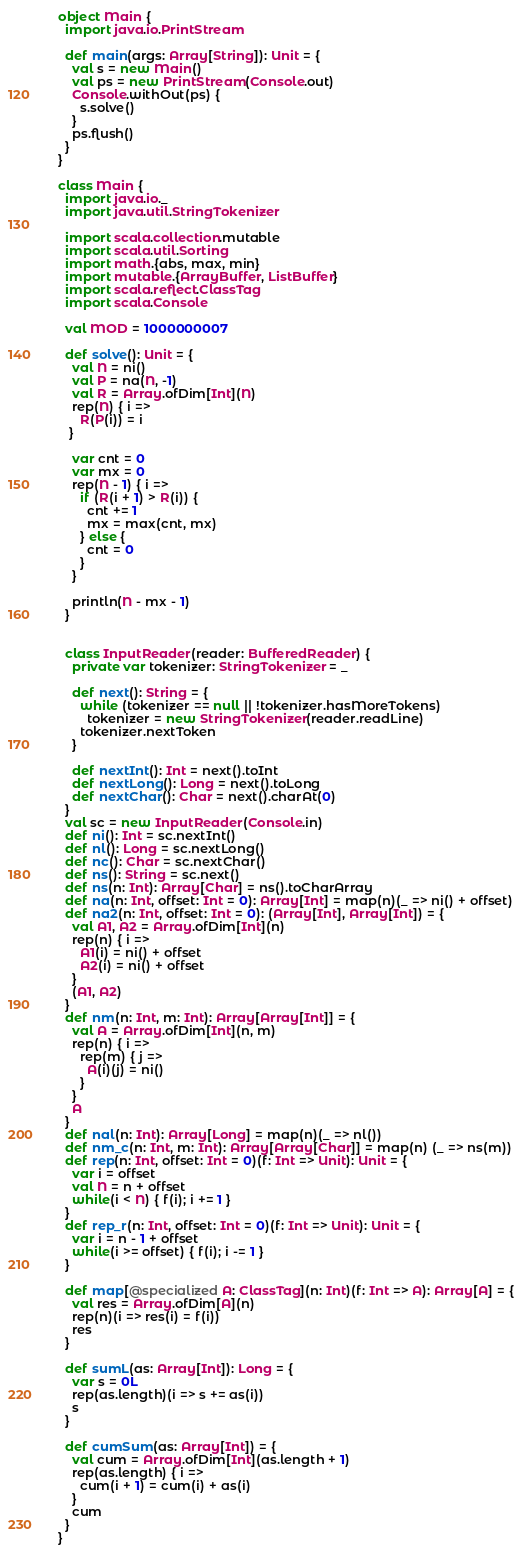<code> <loc_0><loc_0><loc_500><loc_500><_Scala_>object Main {
  import java.io.PrintStream

  def main(args: Array[String]): Unit = {
    val s = new Main()
    val ps = new PrintStream(Console.out)
    Console.withOut(ps) {
      s.solve()
    }
    ps.flush()
  }
}

class Main {
  import java.io._
  import java.util.StringTokenizer

  import scala.collection.mutable
  import scala.util.Sorting
  import math.{abs, max, min}
  import mutable.{ArrayBuffer, ListBuffer}
  import scala.reflect.ClassTag
  import scala.Console

  val MOD = 1000000007

  def solve(): Unit = {
    val N = ni()
    val P = na(N, -1)
    val R = Array.ofDim[Int](N)
    rep(N) { i =>
      R(P(i)) = i
   }

    var cnt = 0
    var mx = 0
    rep(N - 1) { i =>
      if (R(i + 1) > R(i)) {
        cnt += 1
        mx = max(cnt, mx)
      } else {
        cnt = 0
      }
    }

    println(N - mx - 1)
  }


  class InputReader(reader: BufferedReader) {
    private var tokenizer: StringTokenizer = _

    def next(): String = {
      while (tokenizer == null || !tokenizer.hasMoreTokens)
        tokenizer = new StringTokenizer(reader.readLine)
      tokenizer.nextToken
    }

    def nextInt(): Int = next().toInt
    def nextLong(): Long = next().toLong
    def nextChar(): Char = next().charAt(0)
  }
  val sc = new InputReader(Console.in)
  def ni(): Int = sc.nextInt()
  def nl(): Long = sc.nextLong()
  def nc(): Char = sc.nextChar()
  def ns(): String = sc.next()
  def ns(n: Int): Array[Char] = ns().toCharArray
  def na(n: Int, offset: Int = 0): Array[Int] = map(n)(_ => ni() + offset)
  def na2(n: Int, offset: Int = 0): (Array[Int], Array[Int]) = {
    val A1, A2 = Array.ofDim[Int](n)
    rep(n) { i =>
      A1(i) = ni() + offset
      A2(i) = ni() + offset
    }
    (A1, A2)
  }
  def nm(n: Int, m: Int): Array[Array[Int]] = {
    val A = Array.ofDim[Int](n, m)
    rep(n) { i =>
      rep(m) { j =>
        A(i)(j) = ni()
      }
    }
    A
  }
  def nal(n: Int): Array[Long] = map(n)(_ => nl())
  def nm_c(n: Int, m: Int): Array[Array[Char]] = map(n) (_ => ns(m))
  def rep(n: Int, offset: Int = 0)(f: Int => Unit): Unit = {
    var i = offset
    val N = n + offset
    while(i < N) { f(i); i += 1 }
  }
  def rep_r(n: Int, offset: Int = 0)(f: Int => Unit): Unit = {
    var i = n - 1 + offset
    while(i >= offset) { f(i); i -= 1 }
  }

  def map[@specialized A: ClassTag](n: Int)(f: Int => A): Array[A] = {
    val res = Array.ofDim[A](n)
    rep(n)(i => res(i) = f(i))
    res
  }

  def sumL(as: Array[Int]): Long = {
    var s = 0L
    rep(as.length)(i => s += as(i))
    s
  }

  def cumSum(as: Array[Int]) = {
    val cum = Array.ofDim[Int](as.length + 1)
    rep(as.length) { i =>
      cum(i + 1) = cum(i) + as(i)
    }
    cum
  }
}</code> 